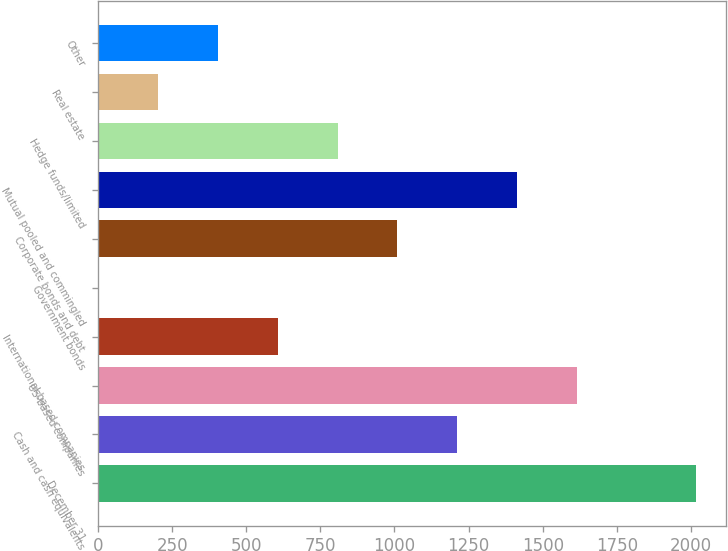Convert chart to OTSL. <chart><loc_0><loc_0><loc_500><loc_500><bar_chart><fcel>December 31<fcel>Cash and cash equivalents<fcel>US-based companies<fcel>International-based companies<fcel>Government bonds<fcel>Corporate bonds and debt<fcel>Mutual pooled and commingled<fcel>Hedge funds/limited<fcel>Real estate<fcel>Other<nl><fcel>2018<fcel>1211.6<fcel>1614.8<fcel>606.8<fcel>2<fcel>1010<fcel>1413.2<fcel>808.4<fcel>203.6<fcel>405.2<nl></chart> 